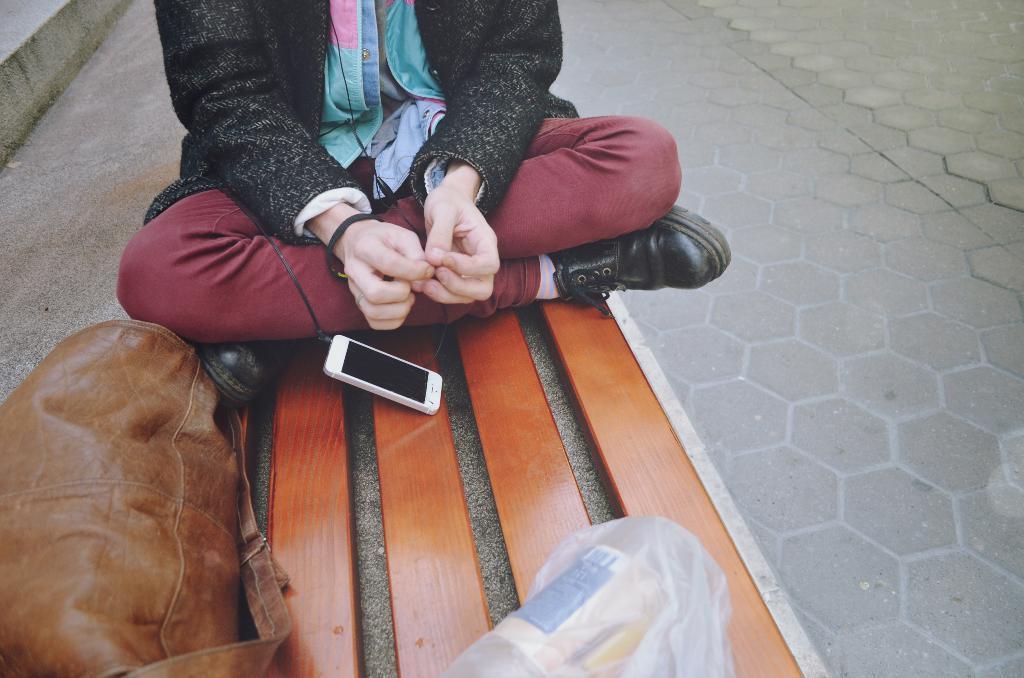Can you describe this image briefly? In this image on a wooden surface, there is a person sitting, a mobile phone, a bag and a cover. On the right, there is pavement and on the left, it seems like steps. 